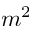<formula> <loc_0><loc_0><loc_500><loc_500>m ^ { 2 }</formula> 